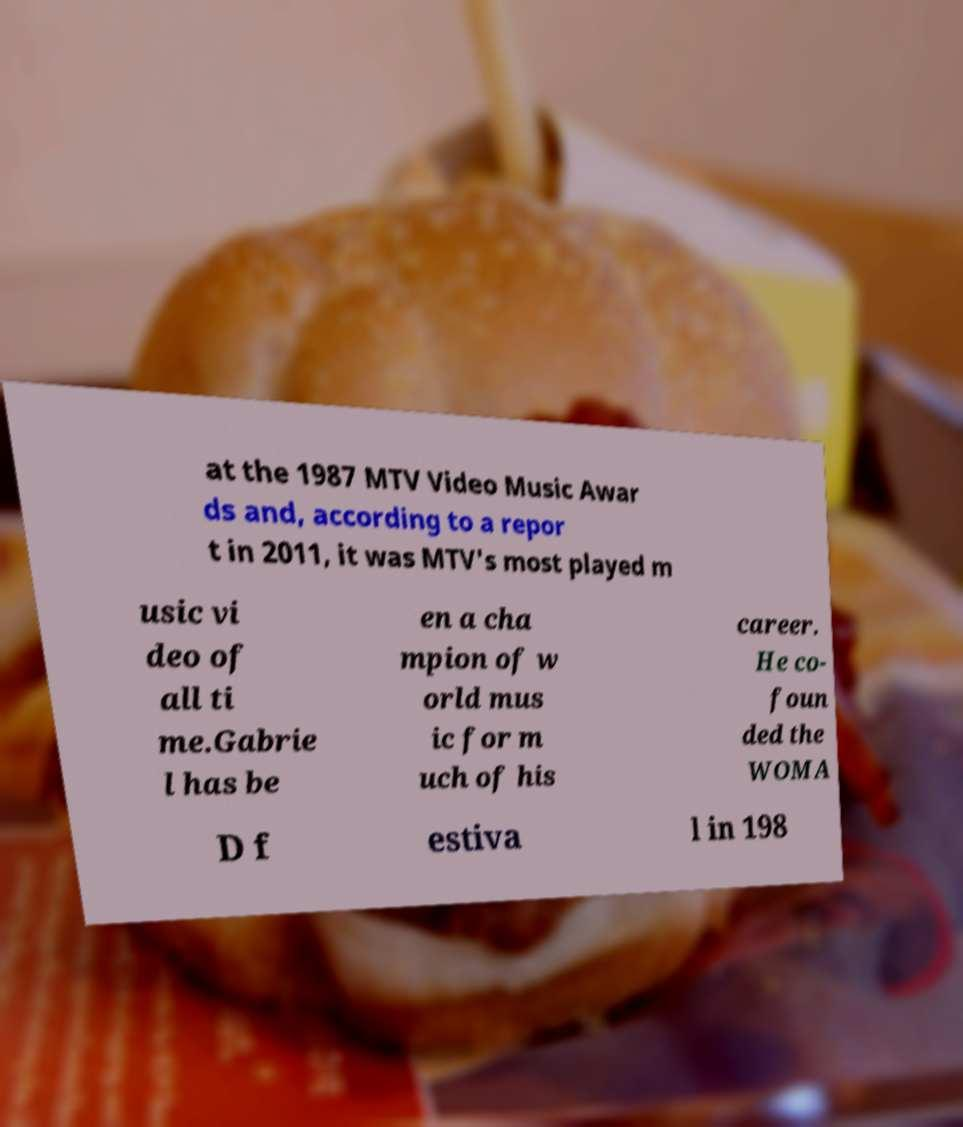Could you assist in decoding the text presented in this image and type it out clearly? at the 1987 MTV Video Music Awar ds and, according to a repor t in 2011, it was MTV's most played m usic vi deo of all ti me.Gabrie l has be en a cha mpion of w orld mus ic for m uch of his career. He co- foun ded the WOMA D f estiva l in 198 